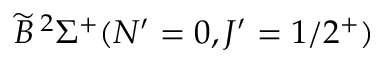<formula> <loc_0><loc_0><loc_500><loc_500>\widetilde { B } \, ^ { 2 } \Sigma ^ { + } ( N ^ { \prime } = 0 , J ^ { \prime } = 1 / 2 ^ { + } )</formula> 